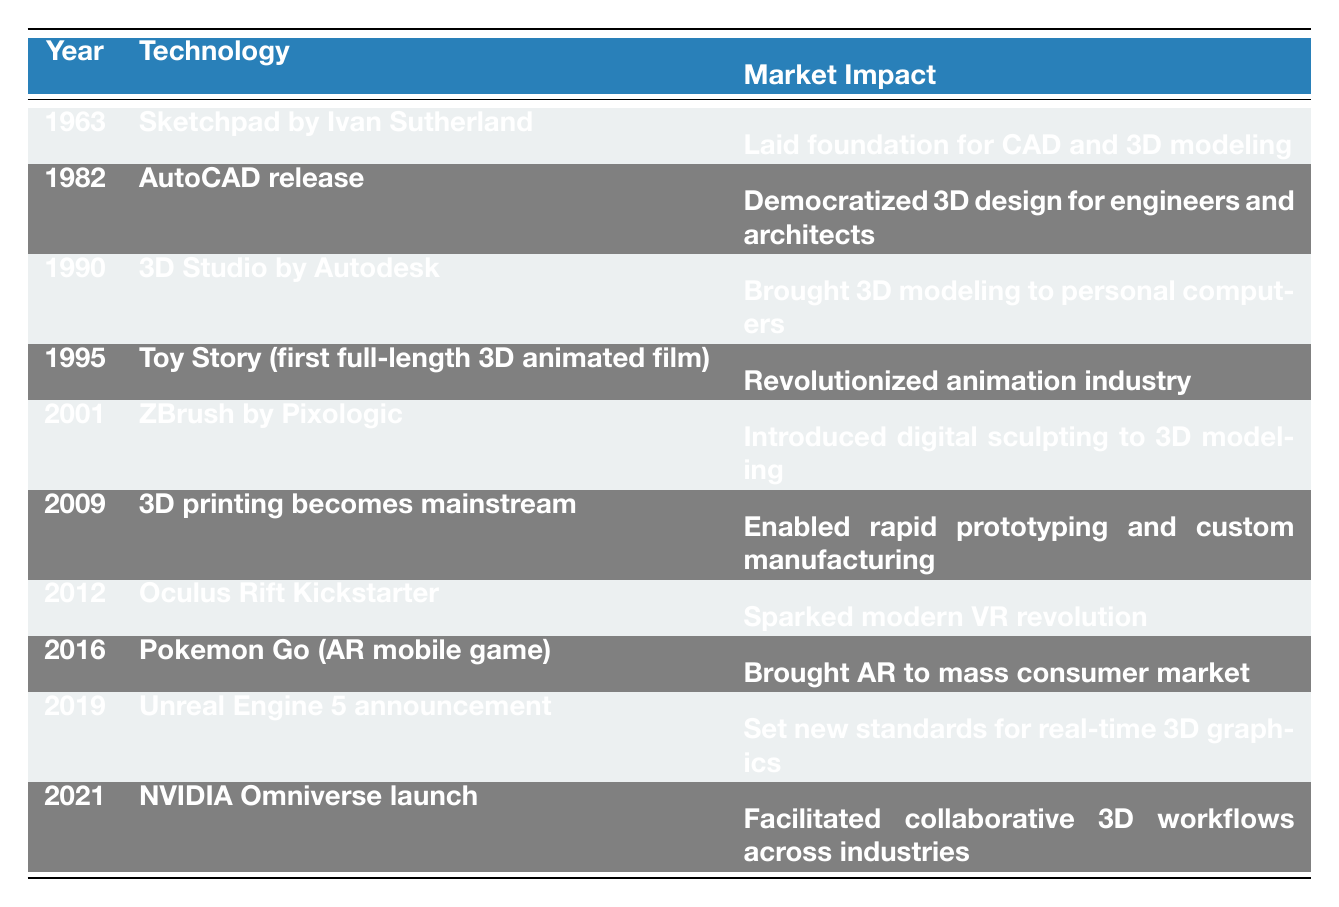What year was the Toy Story released? The table indicates that Toy Story, which is listed as the first full-length 3D animated film, was released in 1995.
Answer: 1995 What technology was introduced in 2001? According to the table, the technology introduced in 2001 is ZBrush by Pixologic.
Answer: ZBrush by Pixologic In which year did 3D printing become mainstream? The table clearly states that 3D printing became mainstream in 2009.
Answer: 2009 How many technologies led to major impacts in the market during the 1990s? There are three technologies listed in the table from the 1990s: 3D Studio by Autodesk in 1990 and Toy Story in 1995, which means the count is 2.
Answer: 2 Was Oculus Rift launched before the release of Pokemon Go? The table indicates that Oculus Rift was launched in 2012 and Pokemon Go was released in 2016, confirming that Oculus Rift was indeed launched earlier.
Answer: Yes What was the market impact of Unreal Engine 5 announcement in 2019? The market impact listed for the Unreal Engine 5 announcement is that it set new standards for real-time 3D graphics.
Answer: Set new standards for real-time 3D graphics Identify a technology that democratized 3D design for engineers and architects. The table identifies AutoCAD release in 1982 as the technology that democratized 3D design for engineers and architects.
Answer: AutoCAD release in 1982 How does the market impact of 3D printing compare between 2009 and that of ZBrush in 2001? The table states that in 2001, ZBrush introduced digital sculpting to 3D modeling, while in 2009, 3D printing enabled rapid prototyping and custom manufacturing. Both played significant roles but in different areas of 3D technology, indicating that they both had major impacts but in distinct markets with varied applications.
Answer: Both had significant impacts but in different areas Which technology sparked the modern VR revolution? The table lists Oculus Rift Kickstarter as the technology that sparked the modern VR revolution in 2012.
Answer: Oculus Rift Kickstarter 